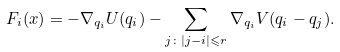Convert formula to latex. <formula><loc_0><loc_0><loc_500><loc_500>F _ { i } ( x ) = - \nabla _ { q _ { i } } U ( q _ { i } ) - \sum _ { j \colon | j - i | \leqslant r } \nabla _ { q _ { i } } V ( q _ { i } - q _ { j } ) .</formula> 